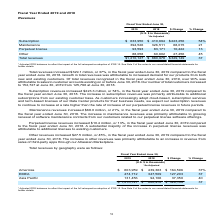According to Atlassian Plc's financial document, What was the increase of maintenance revenues from fiscal year ended 2018 to 2019? According to the financial document, $68.0 million. The relevant text states: "Maintenance revenues increased $68.0 million, or 21%, in the fiscal year ended June 30, 2019 compared to..." Also, What was the main reason for the increase in maintenance revenues? Growing renewal of software maintenance contracts from our customers related to our perpetual license software offerings.. The document states: "maintenance revenues was primarily attributable to growing renewal of software maintenance contracts from our customers related to our perpetual licen..." Also, What was the increase of perpetual license revenues from fiscal year ended 2018 to 2019? According to the financial document, $10.4 million. The relevant text states: "Perpetual license revenues increased $10.4 million, or 13%, in the fiscal year ended June 30, 2019 compared..." Also, can you calculate: For fiscal year ended 2019, what is the difference in subscription revenue and maintenance revenue? Based on the calculation: 633,950-394,526, the result is 239424 (in thousands). This is based on the information: "Maintenance 394,526 326,511 68,015 21 Subscription $ 633,950 $ 410,694 $223,256 54%..." The key data points involved are: 394,526, 633,950. Also, can you calculate: For fiscal year ended 2018, what is the percentage constitution of perpetual license among the total revenue? Based on the calculation: 83,171/880,978, the result is 9.44 (percentage). This is based on the information: "Total revenues $1,210,127 $ 880,978 $329,149 37 Perpetual license 93,593 83,171 10,422 13..." The key data points involved are: 83,171, 880,978. Also, can you calculate: What is the average maintenance revenues for fiscal year ended 2018 and 2019? To answer this question, I need to perform calculations using the financial data. The calculation is: (394,526+326,511)/2, which equals 360518.5 (in thousands). This is based on the information: "Maintenance 394,526 326,511 68,015 21 Maintenance 394,526 326,511 68,015 21..." The key data points involved are: 326,511, 394,526. 